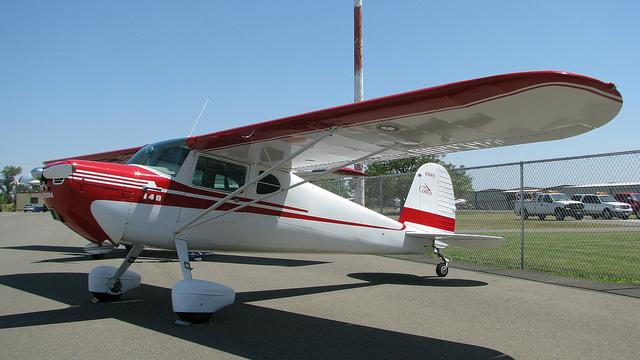How many wheels are used on the bottom of this aircraft? Please explain your reasoning. three. There are two wheels on the front, and one wheel on the back of the aircraft. 